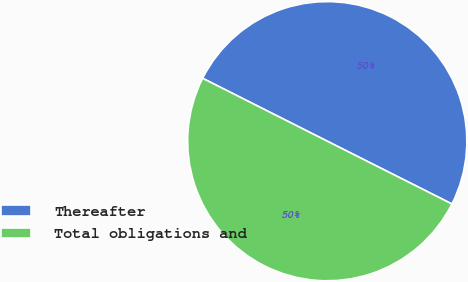Convert chart. <chart><loc_0><loc_0><loc_500><loc_500><pie_chart><fcel>Thereafter<fcel>Total obligations and<nl><fcel>49.99%<fcel>50.01%<nl></chart> 